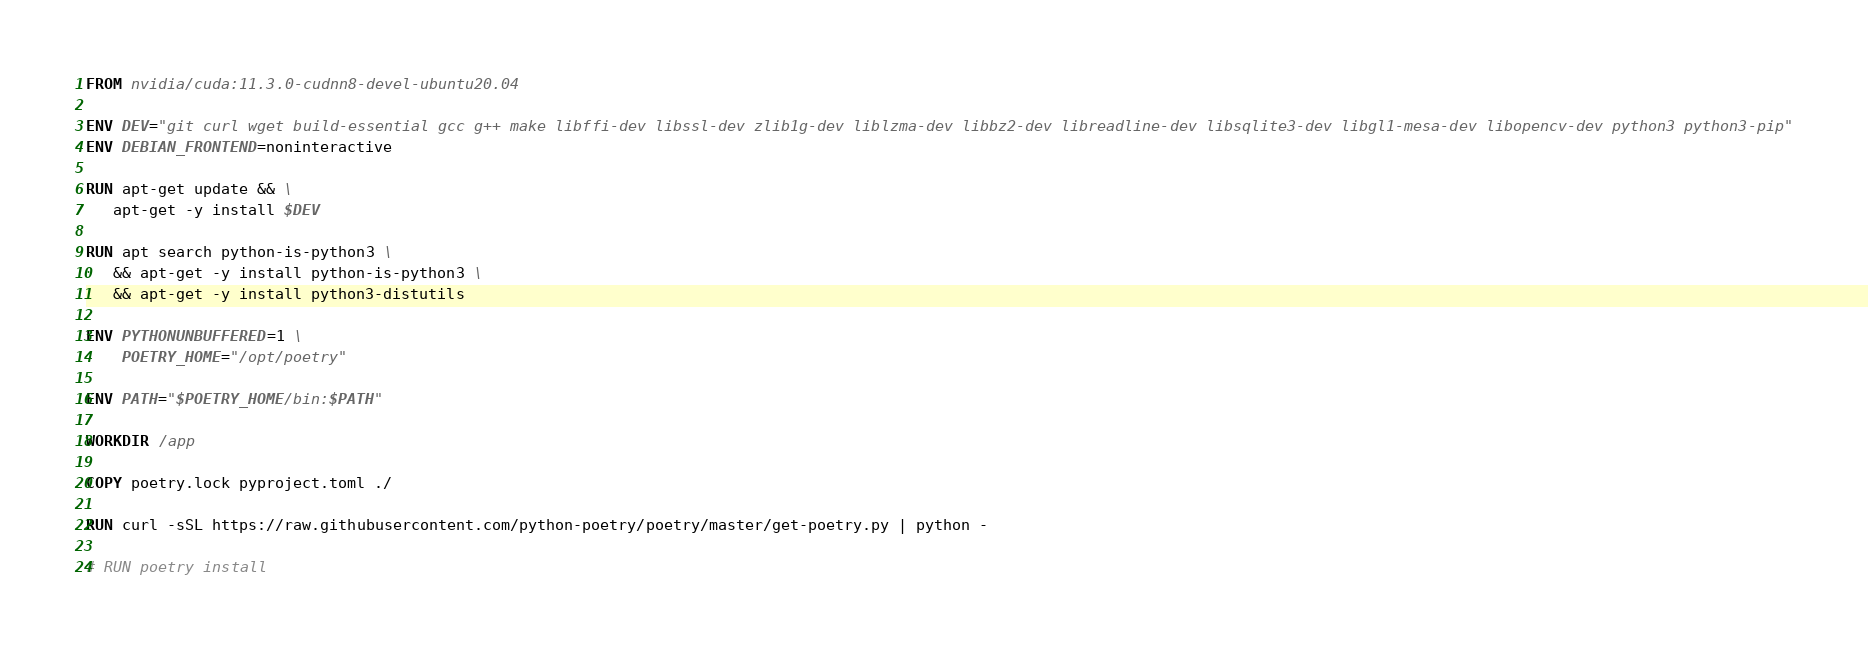Convert code to text. <code><loc_0><loc_0><loc_500><loc_500><_Dockerfile_>FROM nvidia/cuda:11.3.0-cudnn8-devel-ubuntu20.04
 
ENV DEV="git curl wget build-essential gcc g++ make libffi-dev libssl-dev zlib1g-dev liblzma-dev libbz2-dev libreadline-dev libsqlite3-dev libgl1-mesa-dev libopencv-dev python3 python3-pip"
ENV DEBIAN_FRONTEND=noninteractive
 
RUN apt-get update && \
   apt-get -y install $DEV

RUN apt search python-is-python3 \
   && apt-get -y install python-is-python3 \
   && apt-get -y install python3-distutils

ENV PYTHONUNBUFFERED=1 \
    POETRY_HOME="/opt/poetry"

ENV PATH="$POETRY_HOME/bin:$PATH"

WORKDIR /app

COPY poetry.lock pyproject.toml ./

RUN curl -sSL https://raw.githubusercontent.com/python-poetry/poetry/master/get-poetry.py | python -

# RUN poetry install
</code> 